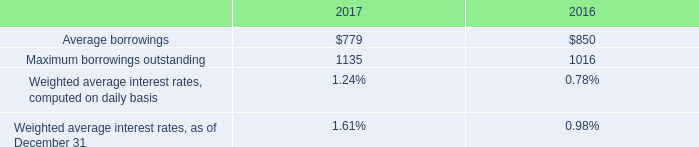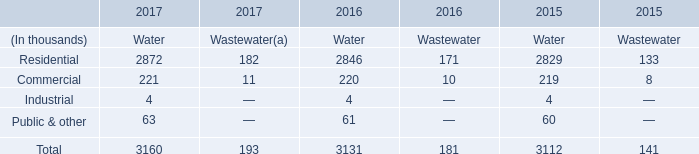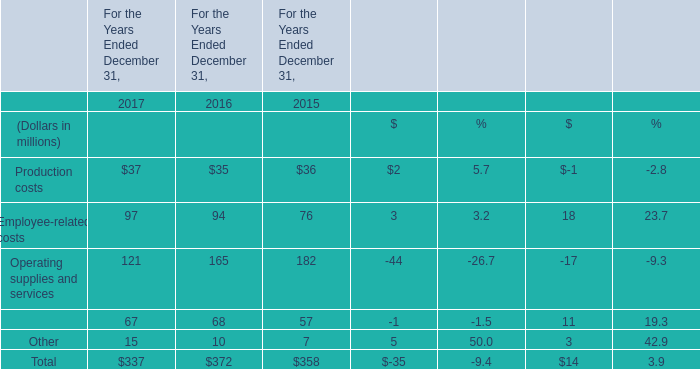What's the sum of the Production costs for For the Years Ended December 31, in the years where Residential for Water is greater than 0? (in million) 
Computations: ((37 + 35) + 36)
Answer: 108.0. 